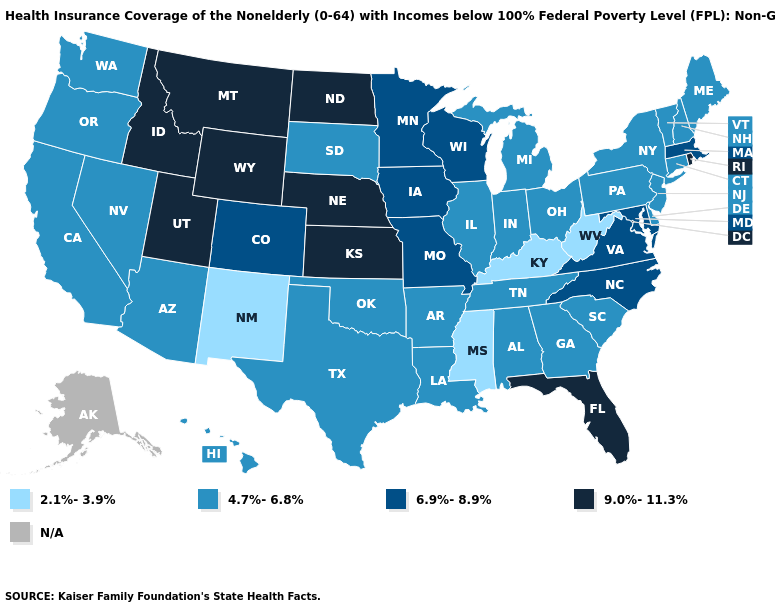What is the value of Florida?
Give a very brief answer. 9.0%-11.3%. What is the lowest value in states that border Vermont?
Concise answer only. 4.7%-6.8%. Which states have the lowest value in the West?
Short answer required. New Mexico. What is the value of Virginia?
Quick response, please. 6.9%-8.9%. What is the highest value in states that border Washington?
Concise answer only. 9.0%-11.3%. Which states have the highest value in the USA?
Concise answer only. Florida, Idaho, Kansas, Montana, Nebraska, North Dakota, Rhode Island, Utah, Wyoming. What is the lowest value in the USA?
Keep it brief. 2.1%-3.9%. What is the value of New Mexico?
Give a very brief answer. 2.1%-3.9%. Which states have the highest value in the USA?
Give a very brief answer. Florida, Idaho, Kansas, Montana, Nebraska, North Dakota, Rhode Island, Utah, Wyoming. Among the states that border Connecticut , which have the highest value?
Concise answer only. Rhode Island. What is the lowest value in the USA?
Quick response, please. 2.1%-3.9%. What is the highest value in the USA?
Quick response, please. 9.0%-11.3%. Which states have the highest value in the USA?
Be succinct. Florida, Idaho, Kansas, Montana, Nebraska, North Dakota, Rhode Island, Utah, Wyoming. What is the lowest value in the USA?
Short answer required. 2.1%-3.9%. What is the lowest value in states that border Idaho?
Give a very brief answer. 4.7%-6.8%. 